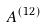Convert formula to latex. <formula><loc_0><loc_0><loc_500><loc_500>A ^ { ( 1 2 ) }</formula> 